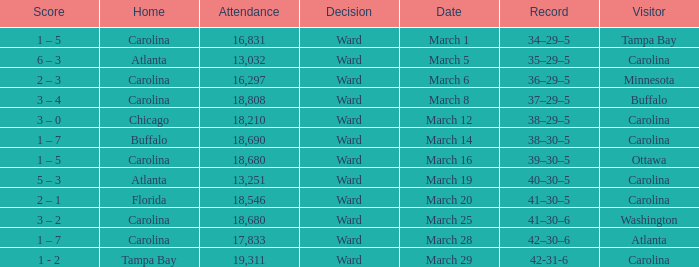What is the Record when Buffalo is at Home? 38–30–5. 